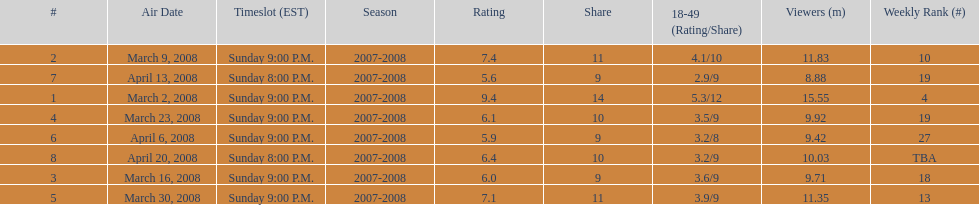What episode had the highest rating? March 2, 2008. 